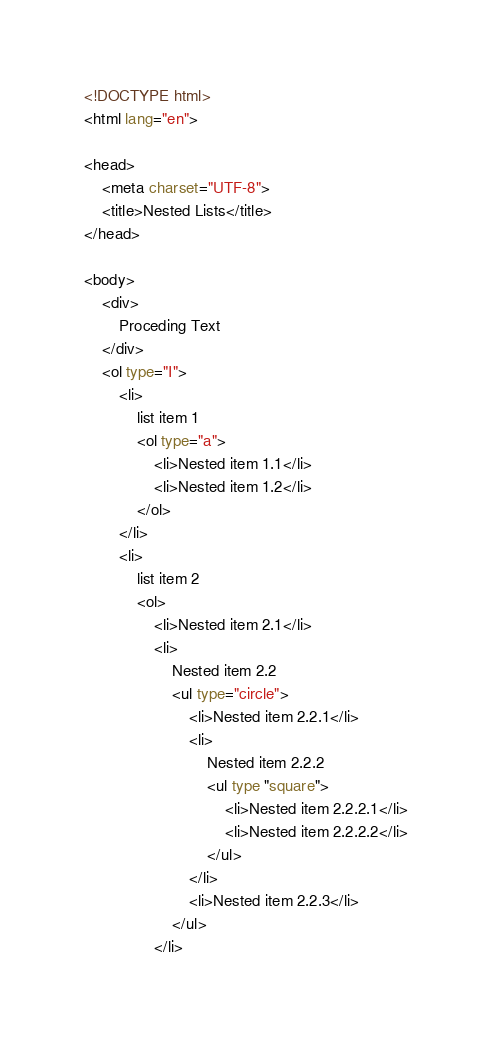<code> <loc_0><loc_0><loc_500><loc_500><_HTML_><!DOCTYPE html>
<html lang="en">

<head>
    <meta charset="UTF-8">
    <title>Nested Lists</title>
</head>

<body>
    <div>
        Proceding Text
    </div>
    <ol type="I">
        <li>
            list item 1
            <ol type="a">
                <li>Nested item 1.1</li>
                <li>Nested item 1.2</li>
            </ol>
        </li>
        <li>
            list item 2
            <ol>
                <li>Nested item 2.1</li>
                <li>
                    Nested item 2.2
                    <ul type="circle">
                        <li>Nested item 2.2.1</li>
                        <li>
                            Nested item 2.2.2
                            <ul type "square">
                                <li>Nested item 2.2.2.1</li>
                                <li>Nested item 2.2.2.2</li>
                            </ul>
                        </li>
                        <li>Nested item 2.2.3</li>
                    </ul>
                </li></code> 